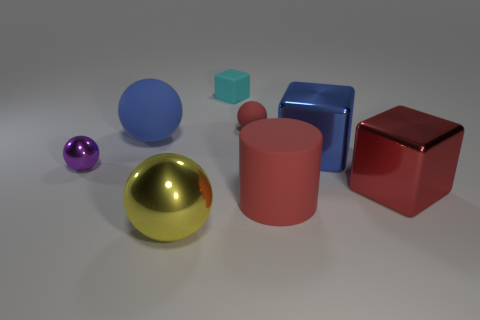What is the shape of the shiny thing that is the same color as the large matte cylinder?
Offer a very short reply. Cube. Are there fewer large shiny things that are behind the purple metallic object than large yellow metallic balls?
Your answer should be very brief. No. Is there any other thing that is the same shape as the tiny shiny object?
Provide a short and direct response. Yes. Are any cyan things visible?
Give a very brief answer. Yes. Is the number of small rubber things less than the number of red rubber balls?
Ensure brevity in your answer.  No. What number of small green objects are made of the same material as the big blue ball?
Provide a succinct answer. 0. There is a large sphere that is made of the same material as the cylinder; what color is it?
Your answer should be very brief. Blue. The large yellow object is what shape?
Your response must be concise. Sphere. What number of objects have the same color as the cylinder?
Offer a terse response. 2. There is a red rubber thing that is the same size as the cyan block; what shape is it?
Your response must be concise. Sphere. 